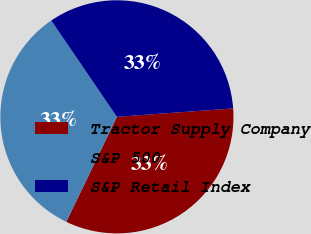Convert chart. <chart><loc_0><loc_0><loc_500><loc_500><pie_chart><fcel>Tractor Supply Company<fcel>S&P 500<fcel>S&P Retail Index<nl><fcel>33.3%<fcel>33.33%<fcel>33.37%<nl></chart> 